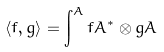<formula> <loc_0><loc_0><loc_500><loc_500>\langle f , g \rangle = \int ^ { A } f A ^ { * } \otimes g A</formula> 